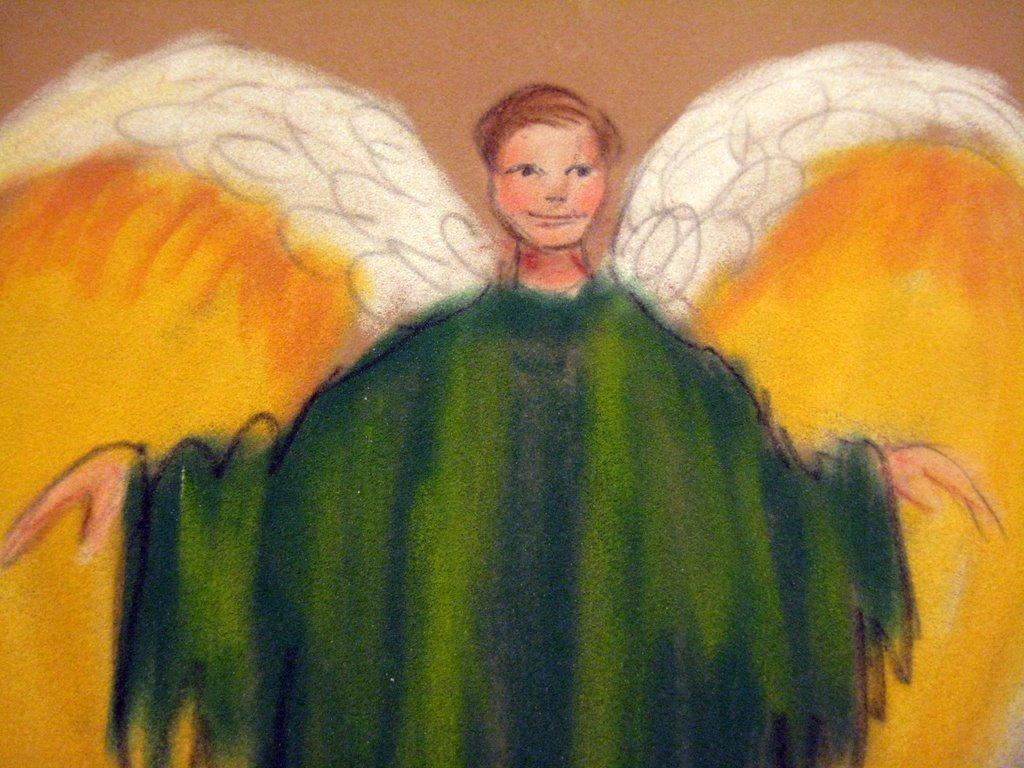What type of artwork is depicted in the image? The image is a painting. Can you describe the main subject of the painting? There is a person in the center of the painting. What items does the person in the painting need to order for dinner? There is no information about ordering dinner in the image, as it is a painting of a person in the center. 